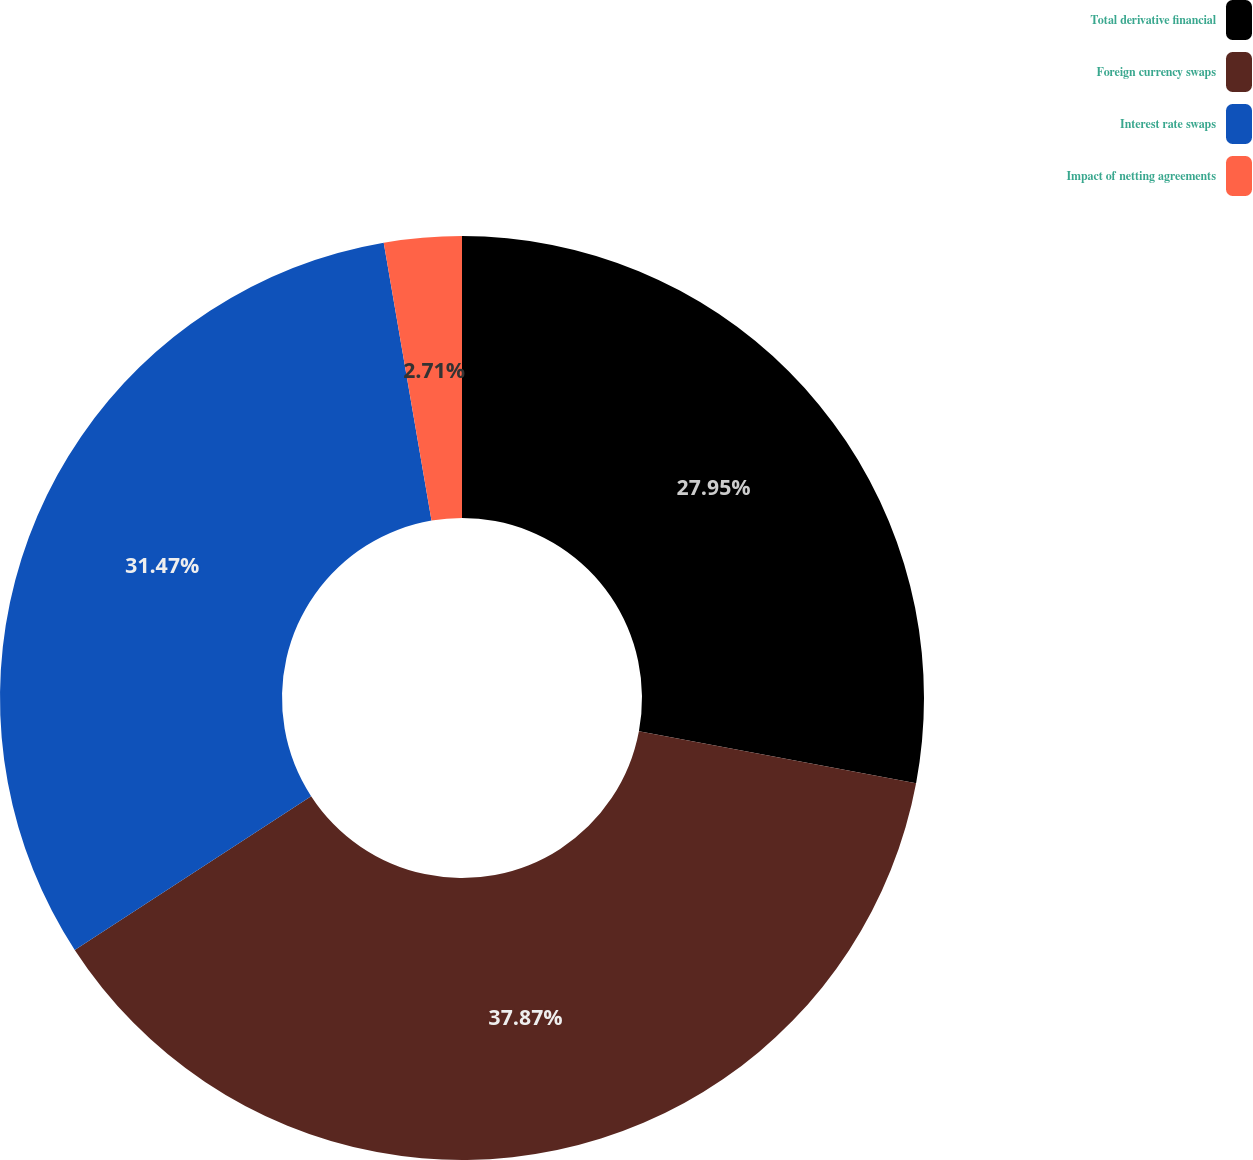Convert chart. <chart><loc_0><loc_0><loc_500><loc_500><pie_chart><fcel>Total derivative financial<fcel>Foreign currency swaps<fcel>Interest rate swaps<fcel>Impact of netting agreements<nl><fcel>27.95%<fcel>37.87%<fcel>31.47%<fcel>2.71%<nl></chart> 